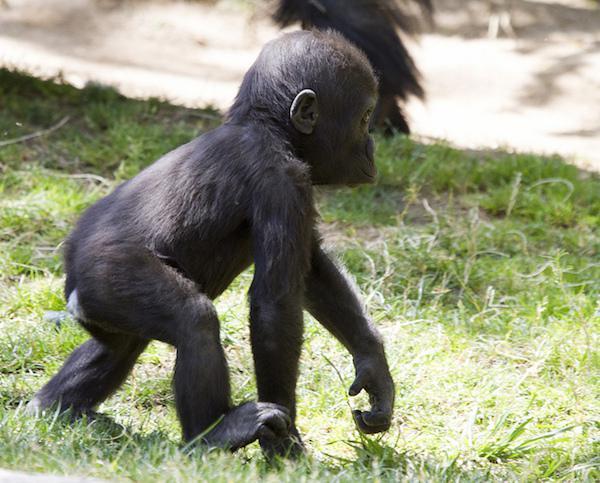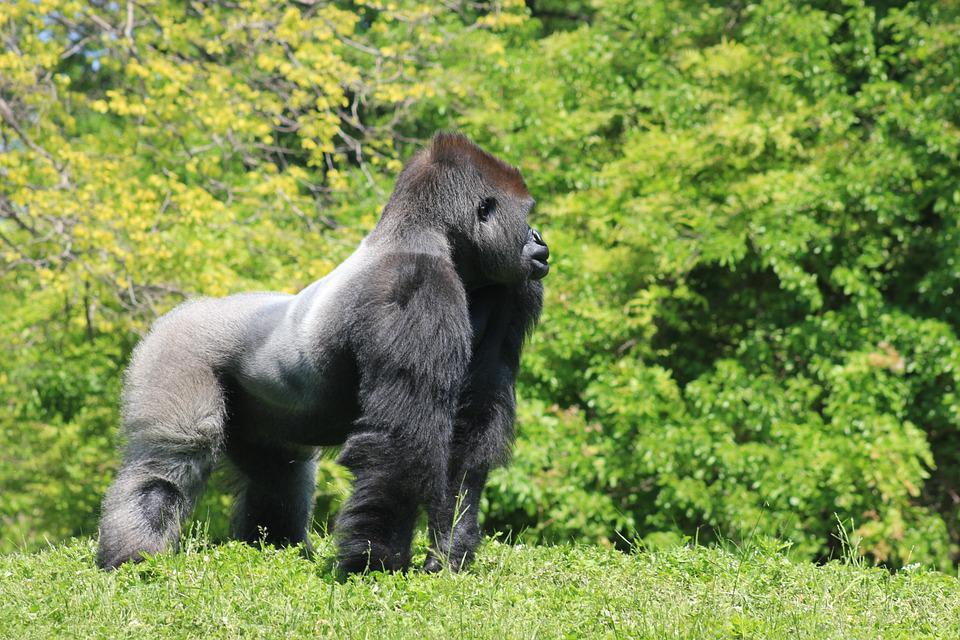The first image is the image on the left, the second image is the image on the right. Given the left and right images, does the statement "Each image features exactly one gorilla, a fierce-looking adult male." hold true? Answer yes or no. No. The first image is the image on the left, the second image is the image on the right. Evaluate the accuracy of this statement regarding the images: "At least one of the images show a baby gorilla". Is it true? Answer yes or no. Yes. 